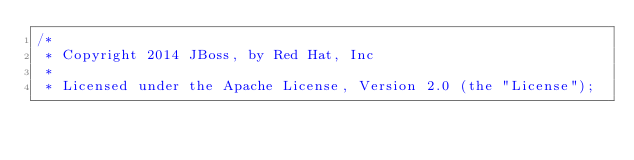<code> <loc_0><loc_0><loc_500><loc_500><_Java_>/*
 * Copyright 2014 JBoss, by Red Hat, Inc
 *
 * Licensed under the Apache License, Version 2.0 (the "License");</code> 